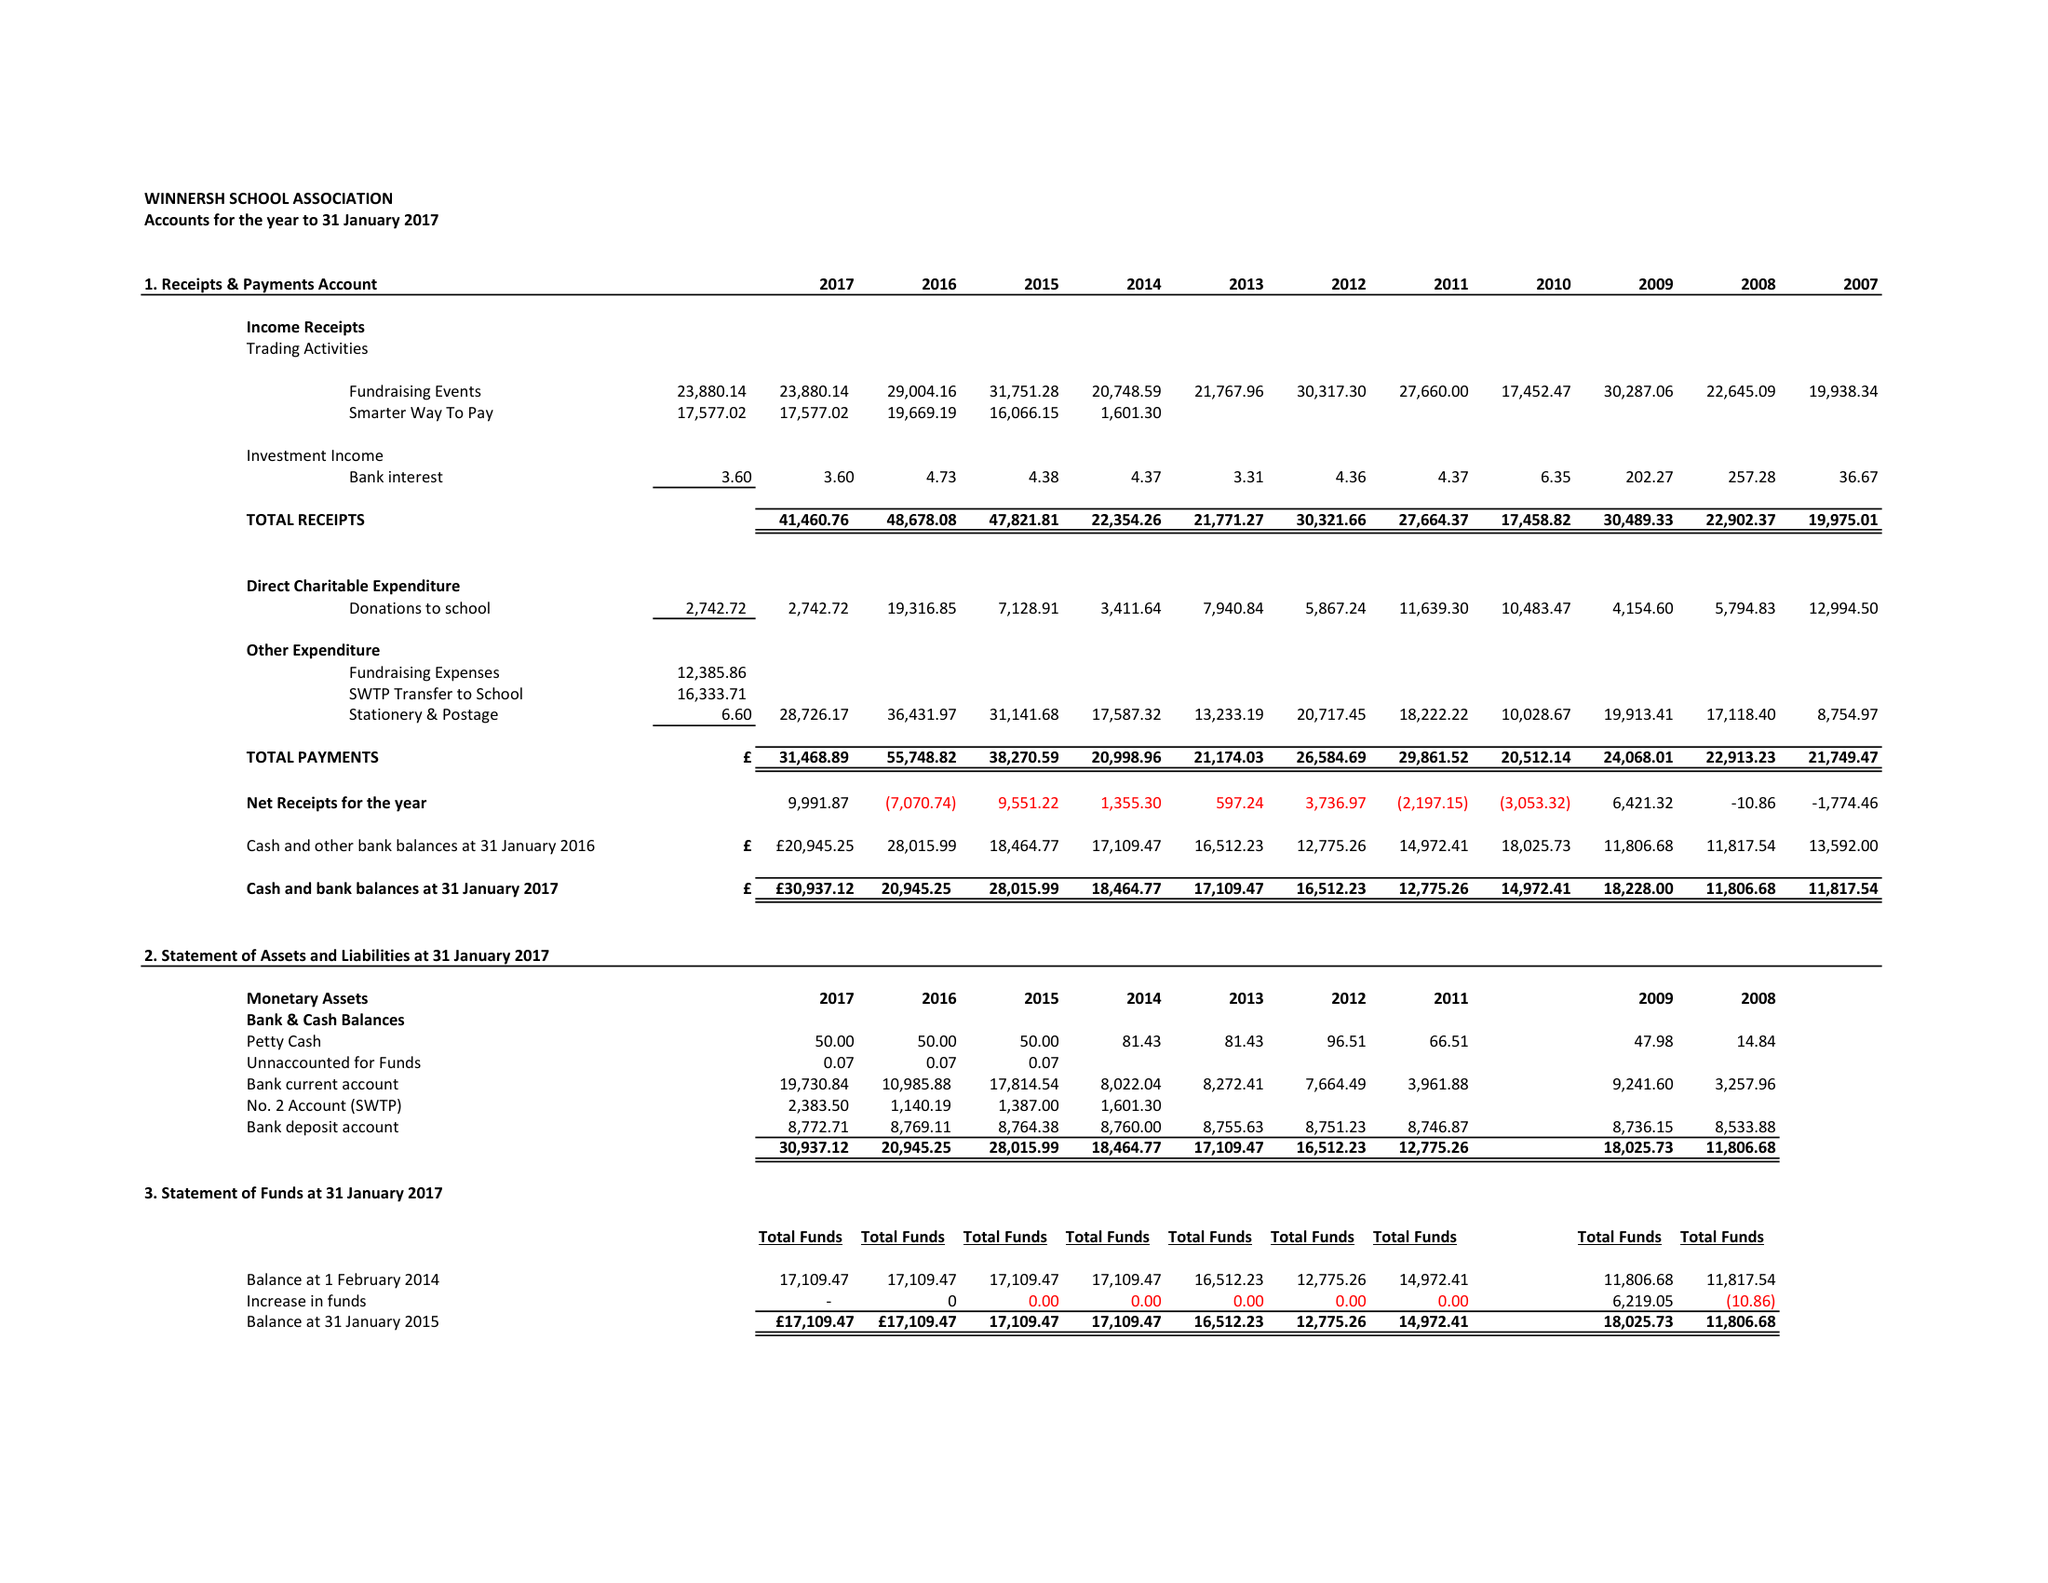What is the value for the charity_number?
Answer the question using a single word or phrase. 276946 